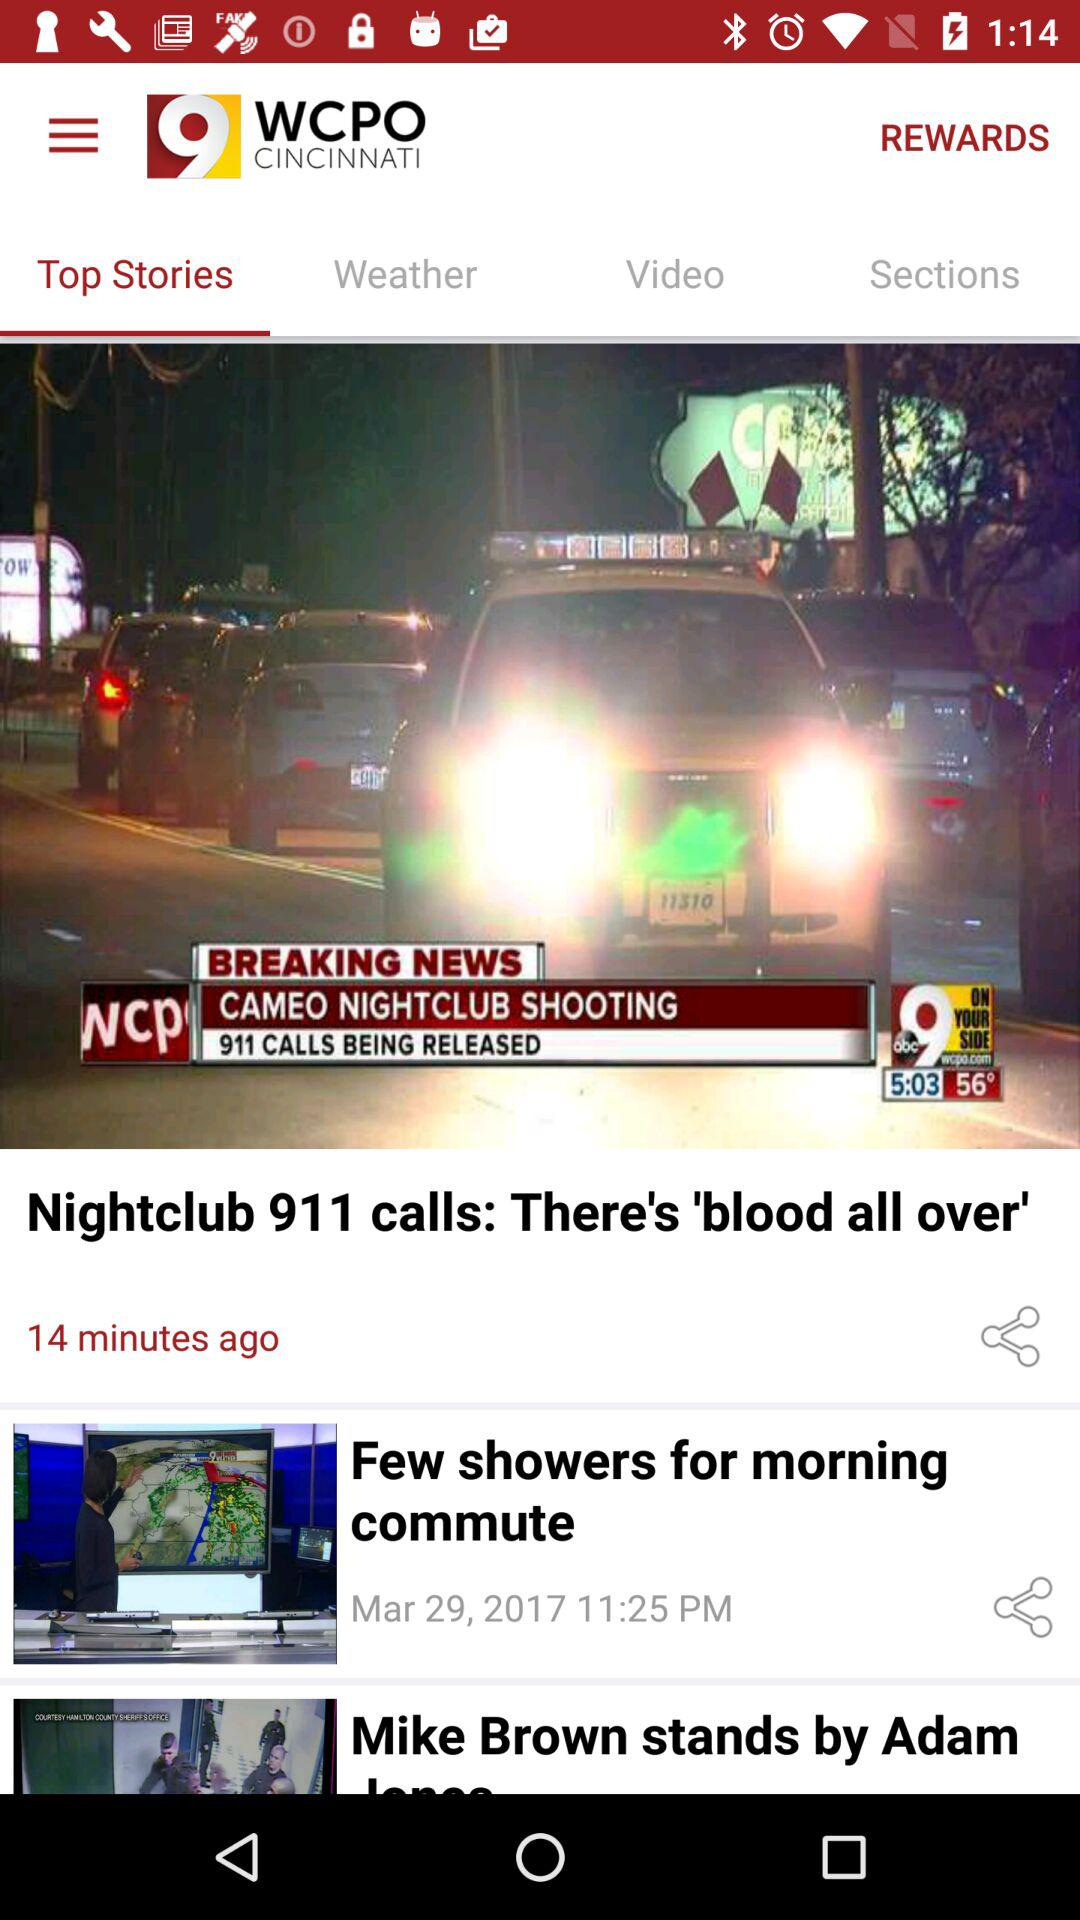What is the date and time when the news about a few showers for the morning was published? The date and time when the news was published is March 29, 2017 at 11:25 PM. 